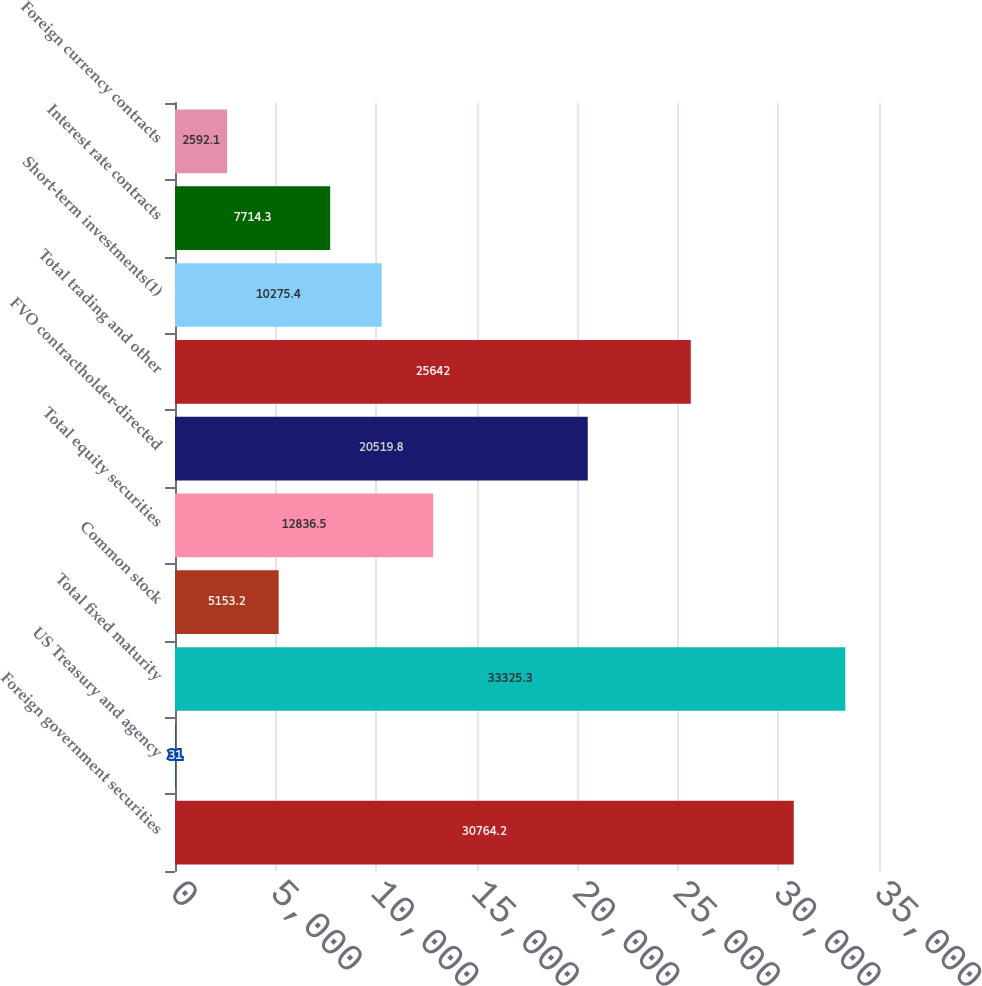Convert chart. <chart><loc_0><loc_0><loc_500><loc_500><bar_chart><fcel>Foreign government securities<fcel>US Treasury and agency<fcel>Total fixed maturity<fcel>Common stock<fcel>Total equity securities<fcel>FVO contractholder-directed<fcel>Total trading and other<fcel>Short-term investments(1)<fcel>Interest rate contracts<fcel>Foreign currency contracts<nl><fcel>30764.2<fcel>31<fcel>33325.3<fcel>5153.2<fcel>12836.5<fcel>20519.8<fcel>25642<fcel>10275.4<fcel>7714.3<fcel>2592.1<nl></chart> 